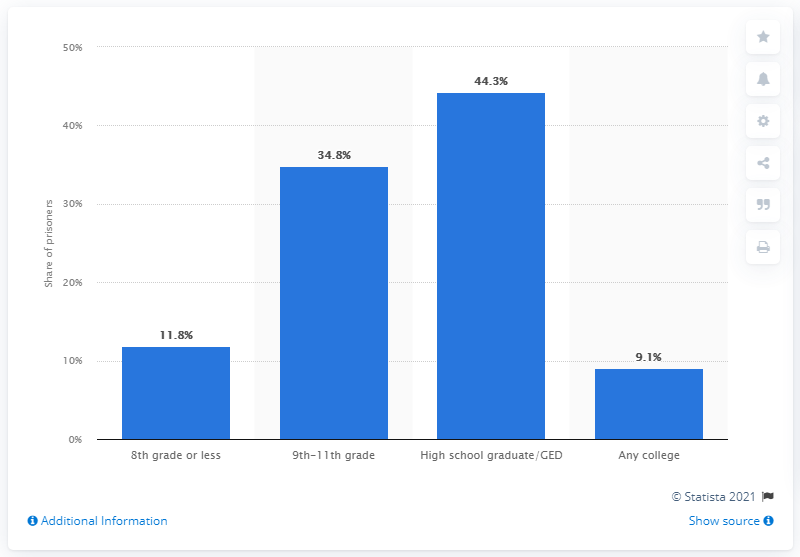Mention a couple of crucial points in this snapshot. According to data, 44.3% of death row prisoners who were surveyed had either graduated from high school or obtained their GED. 